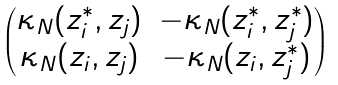<formula> <loc_0><loc_0><loc_500><loc_500>\begin{pmatrix} \kappa _ { N } ( z _ { i } ^ { \ast } , z _ { j } ) & - \kappa _ { N } ( z ^ { \ast } _ { i } , z ^ { \ast } _ { j } ) \\ \kappa _ { N } ( z _ { i } , z _ { j } ) & - \kappa _ { N } ( z _ { i } , z ^ { \ast } _ { j } ) \end{pmatrix}</formula> 